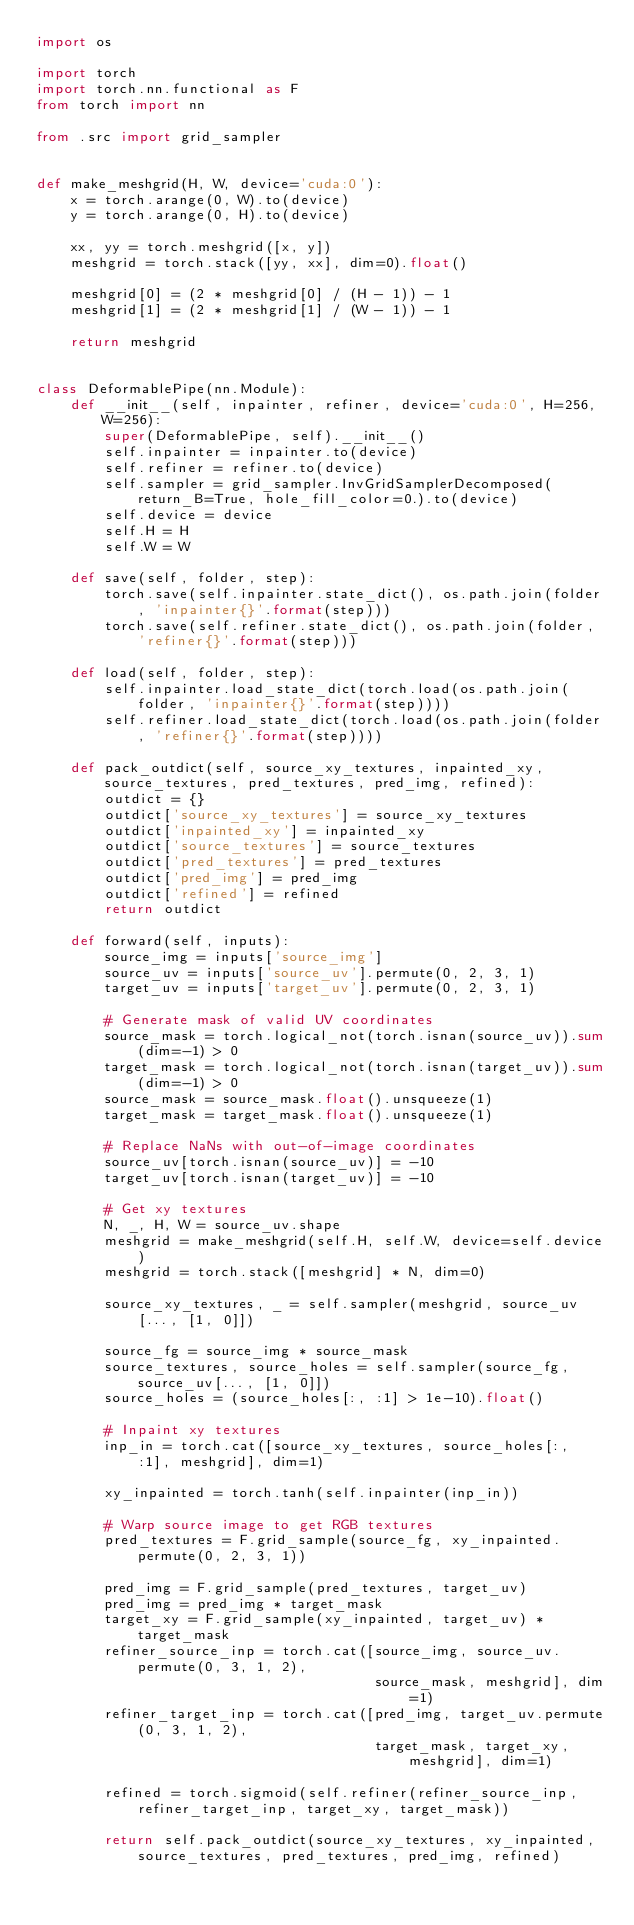Convert code to text. <code><loc_0><loc_0><loc_500><loc_500><_Python_>import os

import torch
import torch.nn.functional as F
from torch import nn

from .src import grid_sampler


def make_meshgrid(H, W, device='cuda:0'):
    x = torch.arange(0, W).to(device)
    y = torch.arange(0, H).to(device)

    xx, yy = torch.meshgrid([x, y])
    meshgrid = torch.stack([yy, xx], dim=0).float()

    meshgrid[0] = (2 * meshgrid[0] / (H - 1)) - 1
    meshgrid[1] = (2 * meshgrid[1] / (W - 1)) - 1

    return meshgrid


class DeformablePipe(nn.Module):
    def __init__(self, inpainter, refiner, device='cuda:0', H=256, W=256):
        super(DeformablePipe, self).__init__()
        self.inpainter = inpainter.to(device)
        self.refiner = refiner.to(device)
        self.sampler = grid_sampler.InvGridSamplerDecomposed(return_B=True, hole_fill_color=0.).to(device)
        self.device = device
        self.H = H
        self.W = W

    def save(self, folder, step):
        torch.save(self.inpainter.state_dict(), os.path.join(folder, 'inpainter{}'.format(step)))
        torch.save(self.refiner.state_dict(), os.path.join(folder, 'refiner{}'.format(step)))

    def load(self, folder, step):
        self.inpainter.load_state_dict(torch.load(os.path.join(folder, 'inpainter{}'.format(step))))
        self.refiner.load_state_dict(torch.load(os.path.join(folder, 'refiner{}'.format(step))))

    def pack_outdict(self, source_xy_textures, inpainted_xy, source_textures, pred_textures, pred_img, refined):
        outdict = {}
        outdict['source_xy_textures'] = source_xy_textures
        outdict['inpainted_xy'] = inpainted_xy
        outdict['source_textures'] = source_textures
        outdict['pred_textures'] = pred_textures
        outdict['pred_img'] = pred_img
        outdict['refined'] = refined
        return outdict

    def forward(self, inputs):
        source_img = inputs['source_img']
        source_uv = inputs['source_uv'].permute(0, 2, 3, 1)
        target_uv = inputs['target_uv'].permute(0, 2, 3, 1)

        # Generate mask of valid UV coordinates
        source_mask = torch.logical_not(torch.isnan(source_uv)).sum(dim=-1) > 0
        target_mask = torch.logical_not(torch.isnan(target_uv)).sum(dim=-1) > 0
        source_mask = source_mask.float().unsqueeze(1)
        target_mask = target_mask.float().unsqueeze(1)

        # Replace NaNs with out-of-image coordinates
        source_uv[torch.isnan(source_uv)] = -10
        target_uv[torch.isnan(target_uv)] = -10

        # Get xy textures
        N, _, H, W = source_uv.shape
        meshgrid = make_meshgrid(self.H, self.W, device=self.device)
        meshgrid = torch.stack([meshgrid] * N, dim=0)

        source_xy_textures, _ = self.sampler(meshgrid, source_uv[..., [1, 0]])

        source_fg = source_img * source_mask
        source_textures, source_holes = self.sampler(source_fg, source_uv[..., [1, 0]])
        source_holes = (source_holes[:, :1] > 1e-10).float()

        # Inpaint xy textures
        inp_in = torch.cat([source_xy_textures, source_holes[:, :1], meshgrid], dim=1)

        xy_inpainted = torch.tanh(self.inpainter(inp_in))

        # Warp source image to get RGB textures
        pred_textures = F.grid_sample(source_fg, xy_inpainted.permute(0, 2, 3, 1))

        pred_img = F.grid_sample(pred_textures, target_uv)
        pred_img = pred_img * target_mask
        target_xy = F.grid_sample(xy_inpainted, target_uv) * target_mask
        refiner_source_inp = torch.cat([source_img, source_uv.permute(0, 3, 1, 2),
                                        source_mask, meshgrid], dim=1)
        refiner_target_inp = torch.cat([pred_img, target_uv.permute(0, 3, 1, 2),
                                        target_mask, target_xy, meshgrid], dim=1)

        refined = torch.sigmoid(self.refiner(refiner_source_inp, refiner_target_inp, target_xy, target_mask))

        return self.pack_outdict(source_xy_textures, xy_inpainted, source_textures, pred_textures, pred_img, refined)

</code> 